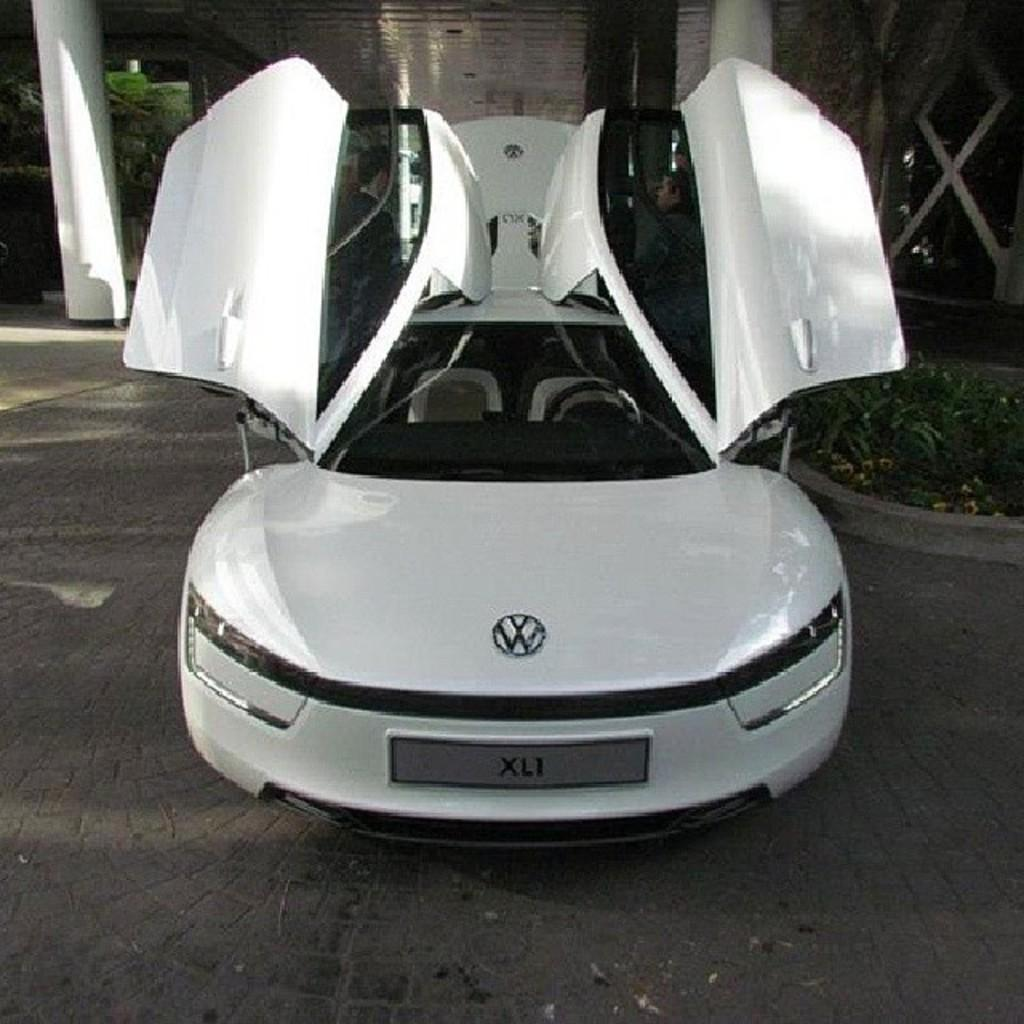What is the main subject of the image? There is a white car in the center of the image. Where is the car located? The car is on the road. What can be seen in the background of the image? There is a building, pillars, trees, grass, and a few other objects in the background of the image. What type of glass is being used to create the rays in the image? There are no rays or glass present in the image; it features a white car on the road with a background containing a building, pillars, trees, grass, and other objects. 